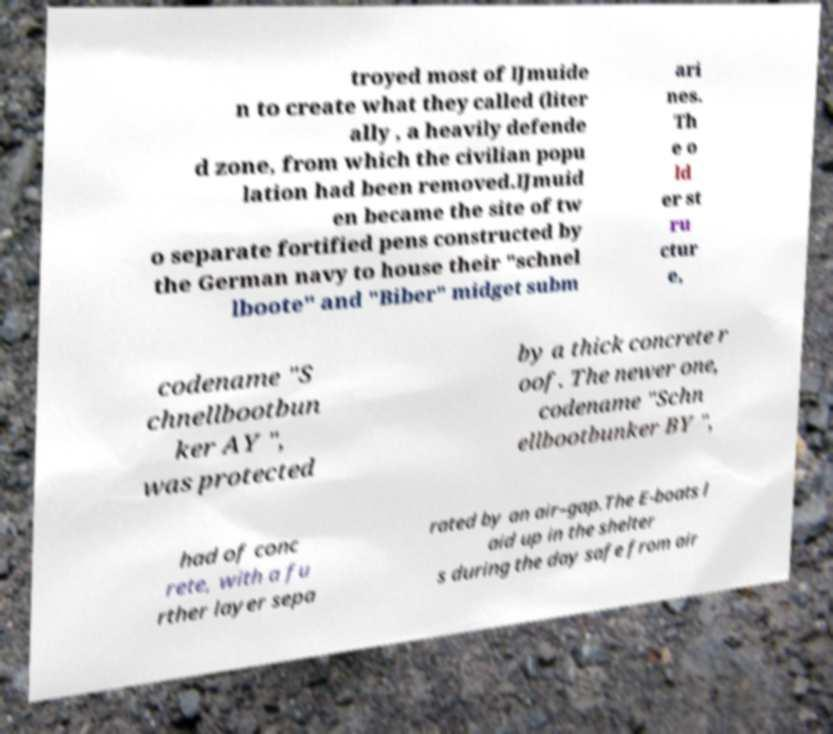For documentation purposes, I need the text within this image transcribed. Could you provide that? troyed most of IJmuide n to create what they called (liter ally , a heavily defende d zone, from which the civilian popu lation had been removed.IJmuid en became the site of tw o separate fortified pens constructed by the German navy to house their "schnel lboote" and "Biber" midget subm ari nes. Th e o ld er st ru ctur e, codename "S chnellbootbun ker AY ", was protected by a thick concrete r oof. The newer one, codename "Schn ellbootbunker BY ", had of conc rete, with a fu rther layer sepa rated by an air–gap.The E-boats l aid up in the shelter s during the day safe from air 